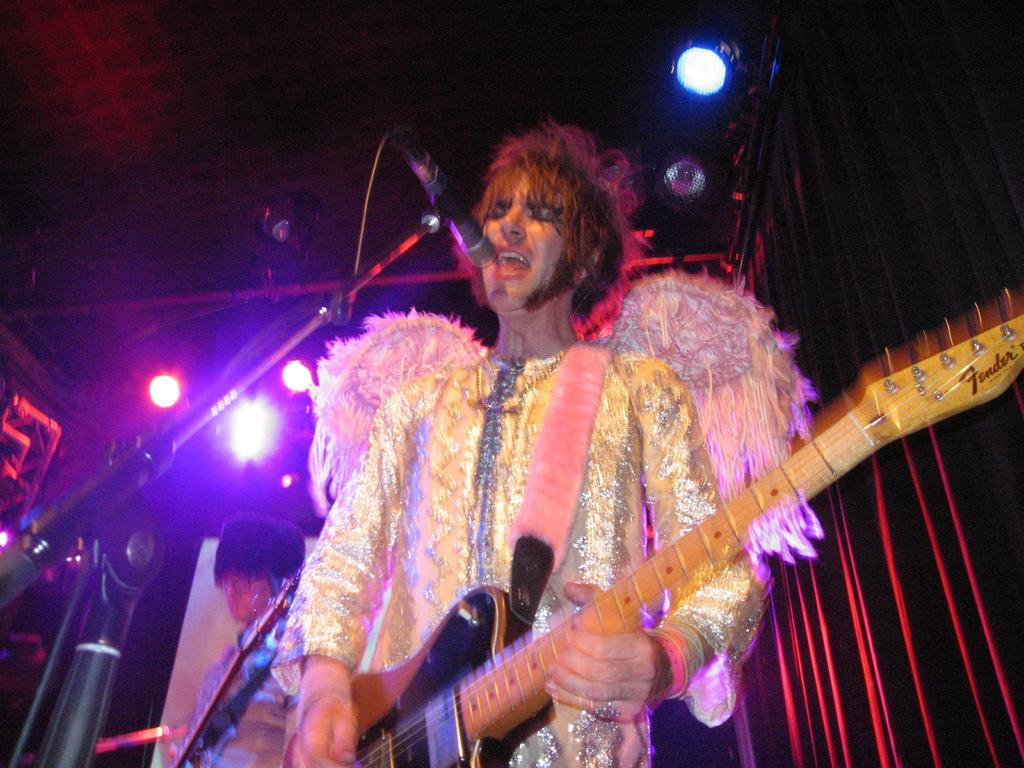What is the man in the image doing? The man is playing a guitar and singing in-front of a mic. What can be seen in the background of the image? There are focusing lights and a red curtain in the image. Are there any other people present in the image? Yes, there is another person standing in the image. How does the snow affect the guitar performance in the image? There is no snow present in the image, so it does not affect the guitar performance. 